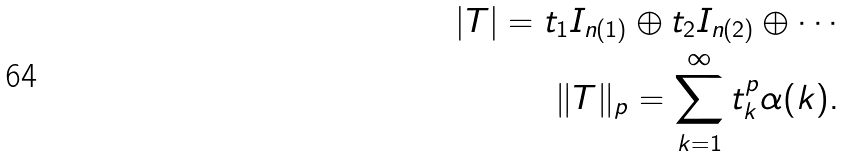Convert formula to latex. <formula><loc_0><loc_0><loc_500><loc_500>| T | = t _ { 1 } I _ { n ( 1 ) } \oplus t _ { 2 } I _ { n ( 2 ) } \oplus \cdots \\ \| T \| _ { p } = \sum _ { k = 1 } ^ { \infty } t _ { k } ^ { p } \alpha ( k ) .</formula> 